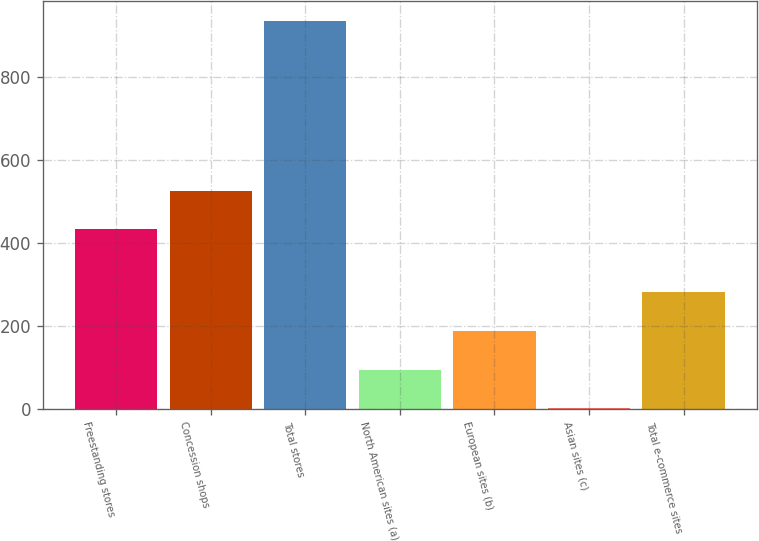Convert chart. <chart><loc_0><loc_0><loc_500><loc_500><bar_chart><fcel>Freestanding stores<fcel>Concession shops<fcel>Total stores<fcel>North American sites (a)<fcel>European sites (b)<fcel>Asian sites (c)<fcel>Total e-commerce sites<nl><fcel>433<fcel>526.4<fcel>936<fcel>95.4<fcel>188.8<fcel>2<fcel>282.2<nl></chart> 